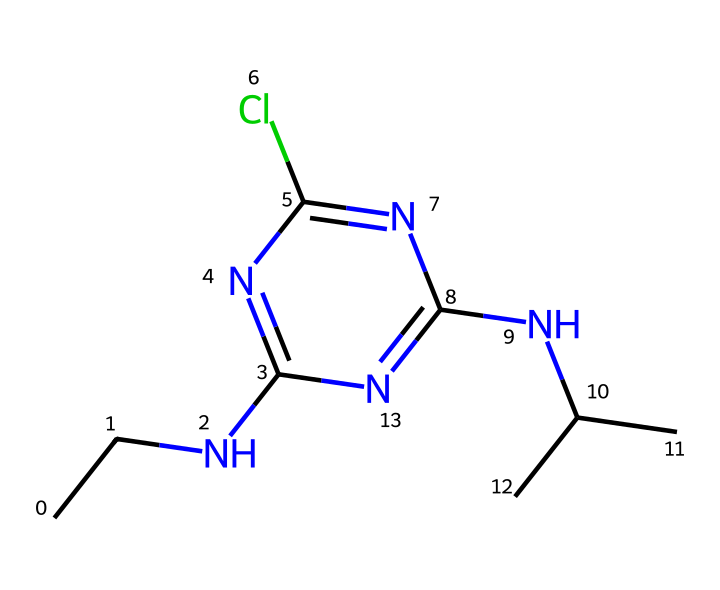What is the main functional group present in atrazine? The structure includes a nitrogen atom bonded to carbon and a halogen (chlorine) atom, indicating the presence of an amine and a chloro group. The amine functional group is responsible for its classification as a herbicide.
Answer: amine How many nitrogen atoms are in atrazine? By inspecting the SMILES representation, we can identify three instances of the nitrogen atom ('N'). Count each 'N' present to arrive at the total.
Answer: three What is the total number of chlorine atoms in the structure? Looking closely at the SMILES, there is one 'Cl' indicated, which signifies the presence of one chlorine atom in the molecular structure of atrazine.
Answer: one Is atrazine a polar or non-polar molecule? The presence of the amine group and the chlorine contributes to polar characteristics, while the carbon backbone tends toward non-polar properties. Analyzing the overall structure indicates that it is likely to be polar due to these functional groups.
Answer: polar What type of herbicide is atrazine? Atrazine falls under the category of selective herbicides, designed to target specific types of plants, particularly broadleaf and grassy weeds, while leaving the desired crops unharmed. This is determined by analyzing its functional groups and mode of action.
Answer: selective Can atrazine affect groundwater quality? Given that atrazine is a persistent herbicide in the environment and can leach into groundwater, analyzing its chemical properties reveals that it can easily migrate through soils, potentially impacting groundwater quality over time.
Answer: yes 